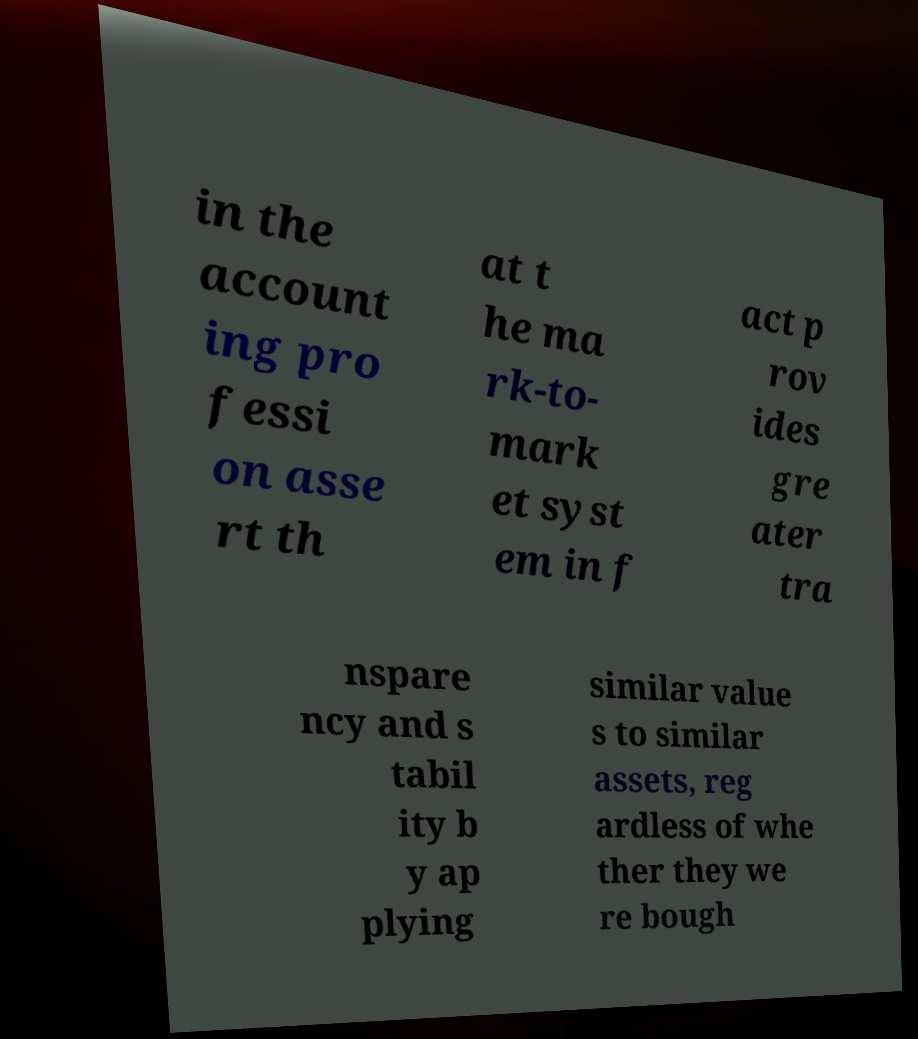Can you read and provide the text displayed in the image?This photo seems to have some interesting text. Can you extract and type it out for me? in the account ing pro fessi on asse rt th at t he ma rk-to- mark et syst em in f act p rov ides gre ater tra nspare ncy and s tabil ity b y ap plying similar value s to similar assets, reg ardless of whe ther they we re bough 